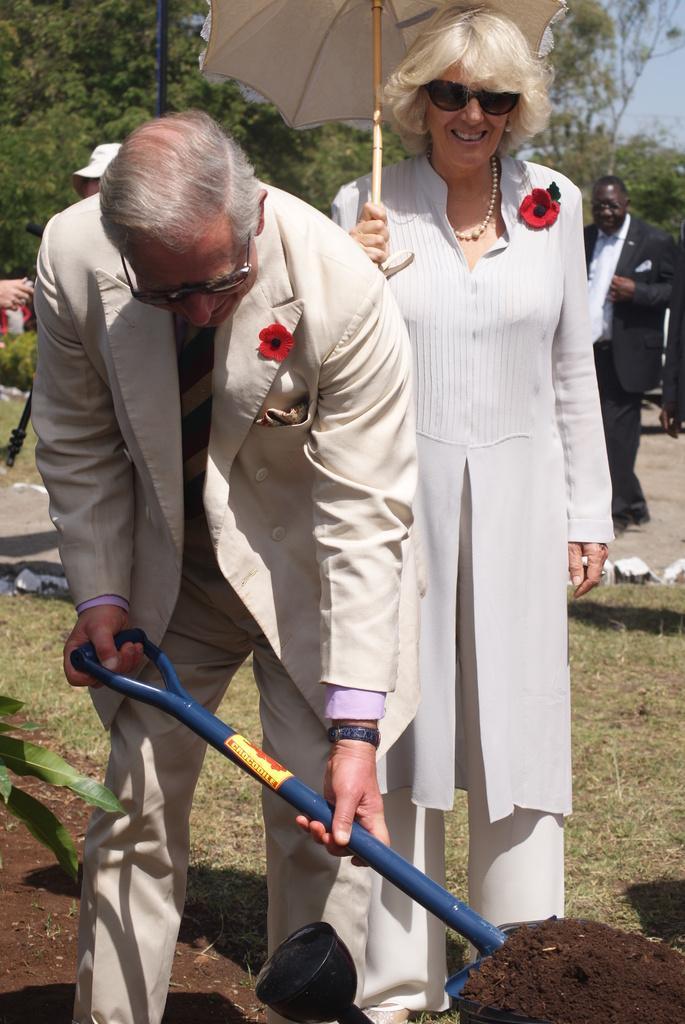How would you summarize this image in a sentence or two? In this picture there is a person standing and holding the tool and there is a woman standing and holding the umbrella. At the back there are group of people and there are trees. At the top there is sky. At the bottom there is grass, mud and there are stones. 